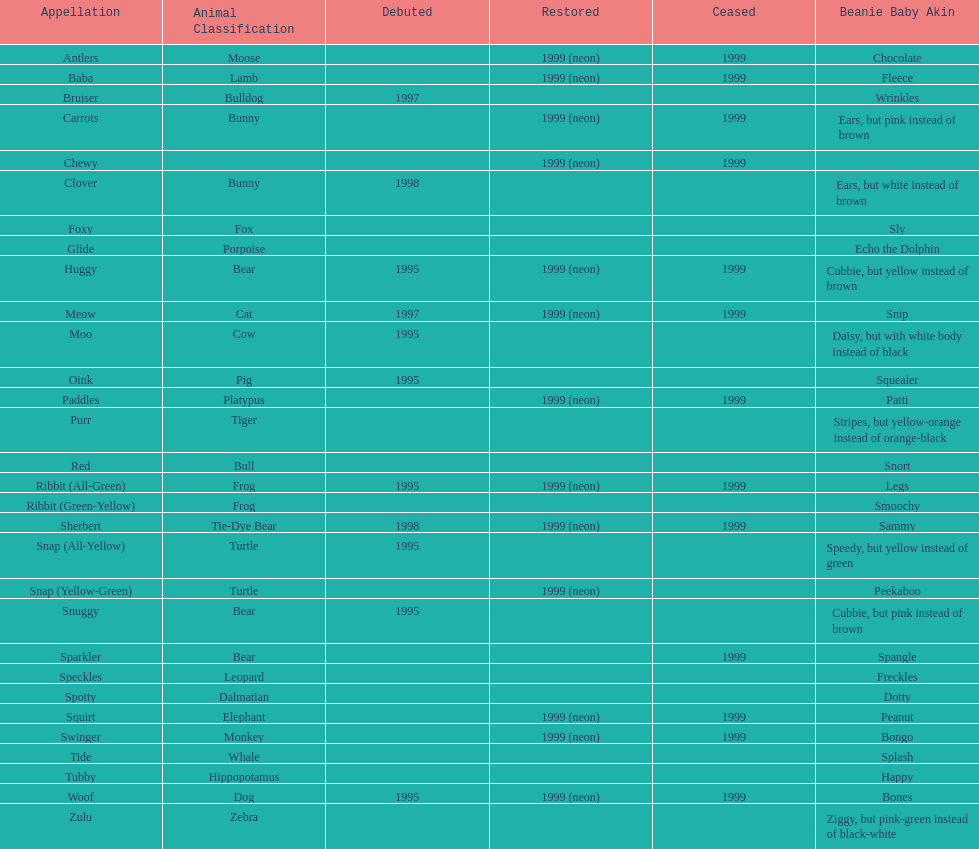Tell me the number of pillow pals reintroduced in 1999. 13. 